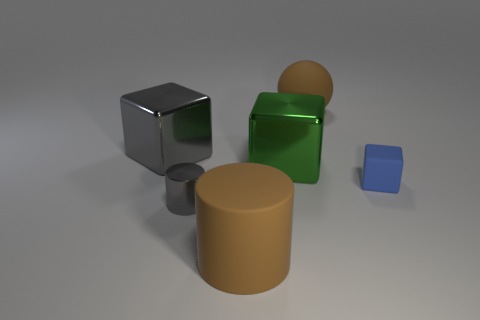There is a large matte object that is the same color as the large sphere; what shape is it?
Give a very brief answer. Cylinder. Do the large ball and the big thing that is in front of the small metal object have the same color?
Your response must be concise. Yes. There is a big block that is left of the large metal cube that is to the right of the big brown object that is to the left of the large sphere; what is its material?
Your answer should be compact. Metal. What is the big gray thing made of?
Provide a succinct answer. Metal. There is a gray shiny thing that is the same shape as the tiny blue object; what size is it?
Your response must be concise. Large. Is the color of the small cylinder the same as the small matte object?
Make the answer very short. No. What number of other things are there of the same material as the tiny blue thing
Offer a very short reply. 2. Is the number of big brown balls behind the large brown rubber cylinder the same as the number of brown cylinders?
Make the answer very short. Yes. There is a gray object that is in front of the blue matte object; is it the same size as the green metal cube?
Offer a very short reply. No. How many brown rubber objects are behind the small rubber cube?
Make the answer very short. 1. 